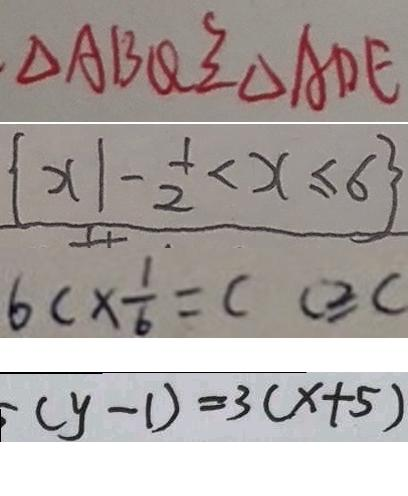Convert formula to latex. <formula><loc_0><loc_0><loc_500><loc_500>\Delta A B Q \cong \Delta A D E 
 \{ x \vert - \frac { 1 } { 2 } < x \leq 6 \} 
 6 c \times \frac { 1 } { b } = c c \geq c 
 ( y - 1 ) = 3 ( x + 5 )</formula> 